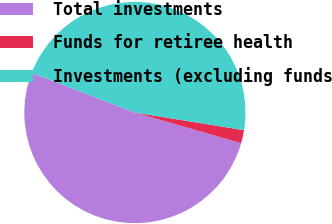<chart> <loc_0><loc_0><loc_500><loc_500><pie_chart><fcel>Total investments<fcel>Funds for retiree health<fcel>Investments (excluding funds<nl><fcel>51.38%<fcel>1.92%<fcel>46.71%<nl></chart> 